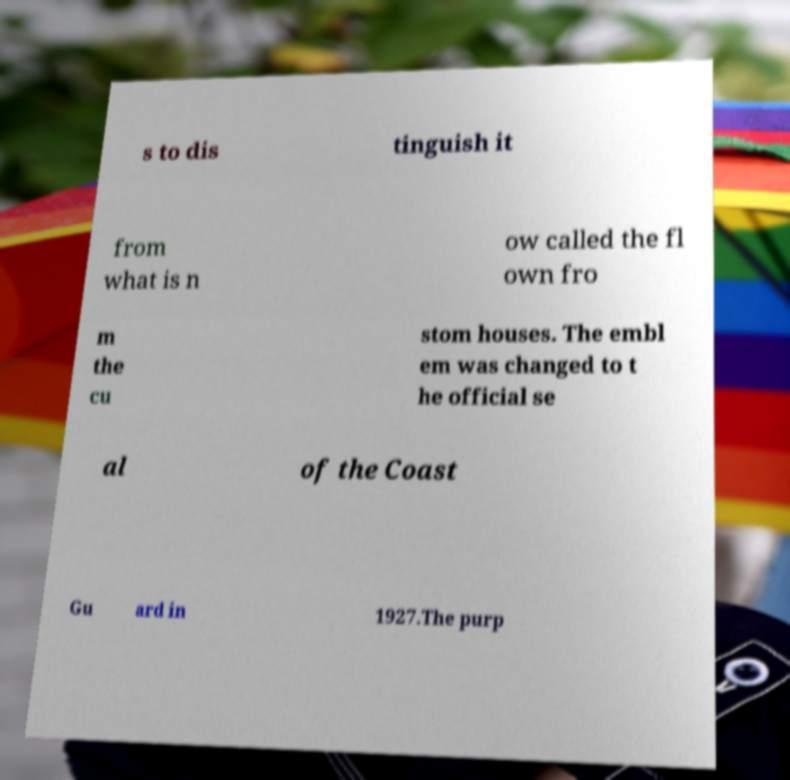Can you read and provide the text displayed in the image?This photo seems to have some interesting text. Can you extract and type it out for me? s to dis tinguish it from what is n ow called the fl own fro m the cu stom houses. The embl em was changed to t he official se al of the Coast Gu ard in 1927.The purp 